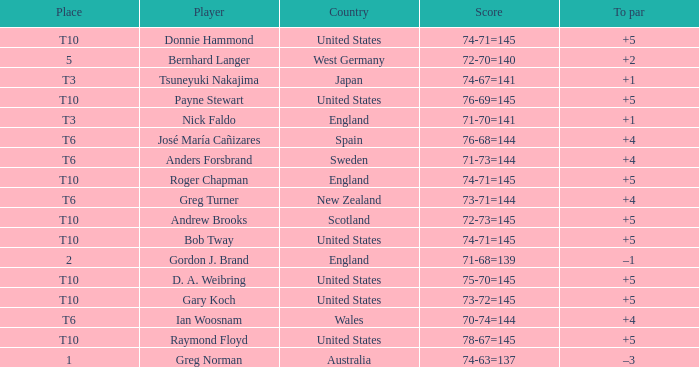Would you mind parsing the complete table? {'header': ['Place', 'Player', 'Country', 'Score', 'To par'], 'rows': [['T10', 'Donnie Hammond', 'United States', '74-71=145', '+5'], ['5', 'Bernhard Langer', 'West Germany', '72-70=140', '+2'], ['T3', 'Tsuneyuki Nakajima', 'Japan', '74-67=141', '+1'], ['T10', 'Payne Stewart', 'United States', '76-69=145', '+5'], ['T3', 'Nick Faldo', 'England', '71-70=141', '+1'], ['T6', 'José María Cañizares', 'Spain', '76-68=144', '+4'], ['T6', 'Anders Forsbrand', 'Sweden', '71-73=144', '+4'], ['T10', 'Roger Chapman', 'England', '74-71=145', '+5'], ['T6', 'Greg Turner', 'New Zealand', '73-71=144', '+4'], ['T10', 'Andrew Brooks', 'Scotland', '72-73=145', '+5'], ['T10', 'Bob Tway', 'United States', '74-71=145', '+5'], ['2', 'Gordon J. Brand', 'England', '71-68=139', '–1'], ['T10', 'D. A. Weibring', 'United States', '75-70=145', '+5'], ['T10', 'Gary Koch', 'United States', '73-72=145', '+5'], ['T6', 'Ian Woosnam', 'Wales', '70-74=144', '+4'], ['T10', 'Raymond Floyd', 'United States', '78-67=145', '+5'], ['1', 'Greg Norman', 'Australia', '74-63=137', '–3']]} What country did Raymond Floyd play for? United States. 